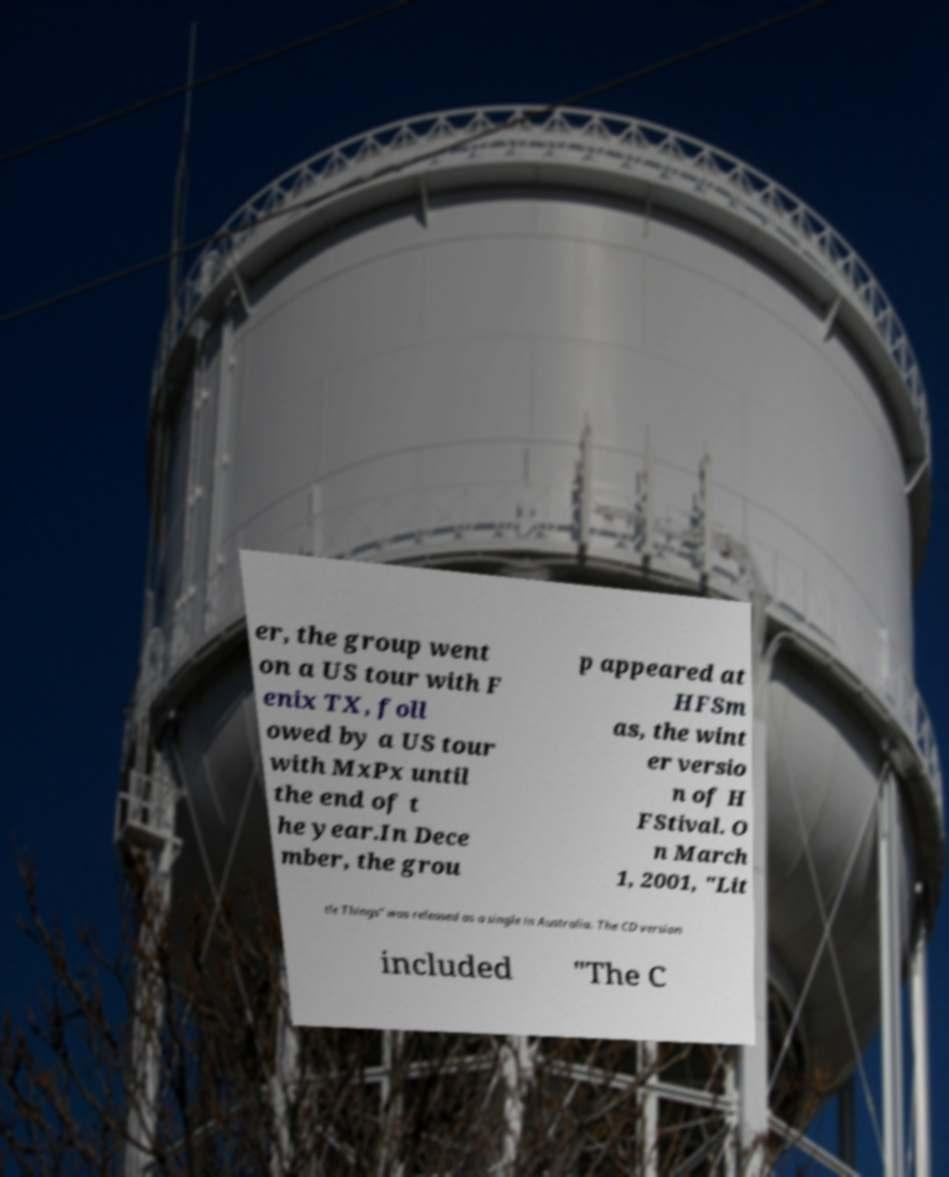Can you accurately transcribe the text from the provided image for me? er, the group went on a US tour with F enix TX, foll owed by a US tour with MxPx until the end of t he year.In Dece mber, the grou p appeared at HFSm as, the wint er versio n of H FStival. O n March 1, 2001, "Lit tle Things" was released as a single in Australia. The CD version included "The C 